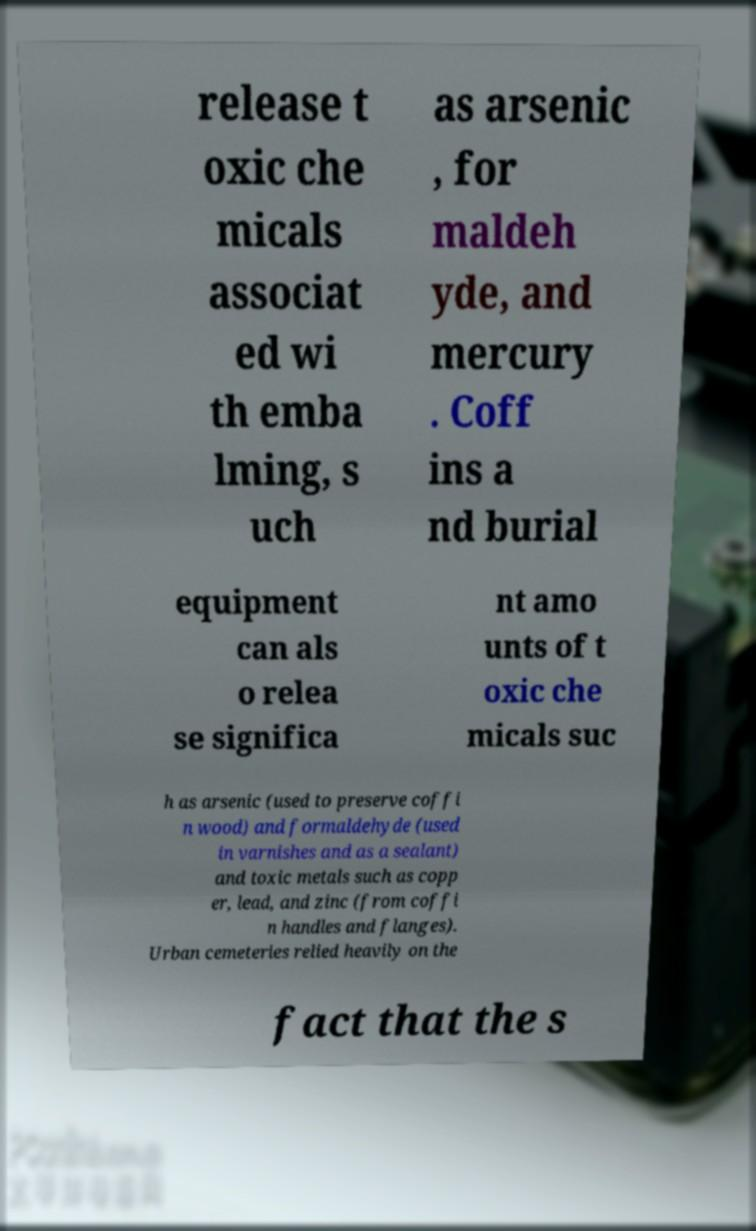There's text embedded in this image that I need extracted. Can you transcribe it verbatim? release t oxic che micals associat ed wi th emba lming, s uch as arsenic , for maldeh yde, and mercury . Coff ins a nd burial equipment can als o relea se significa nt amo unts of t oxic che micals suc h as arsenic (used to preserve coffi n wood) and formaldehyde (used in varnishes and as a sealant) and toxic metals such as copp er, lead, and zinc (from coffi n handles and flanges). Urban cemeteries relied heavily on the fact that the s 